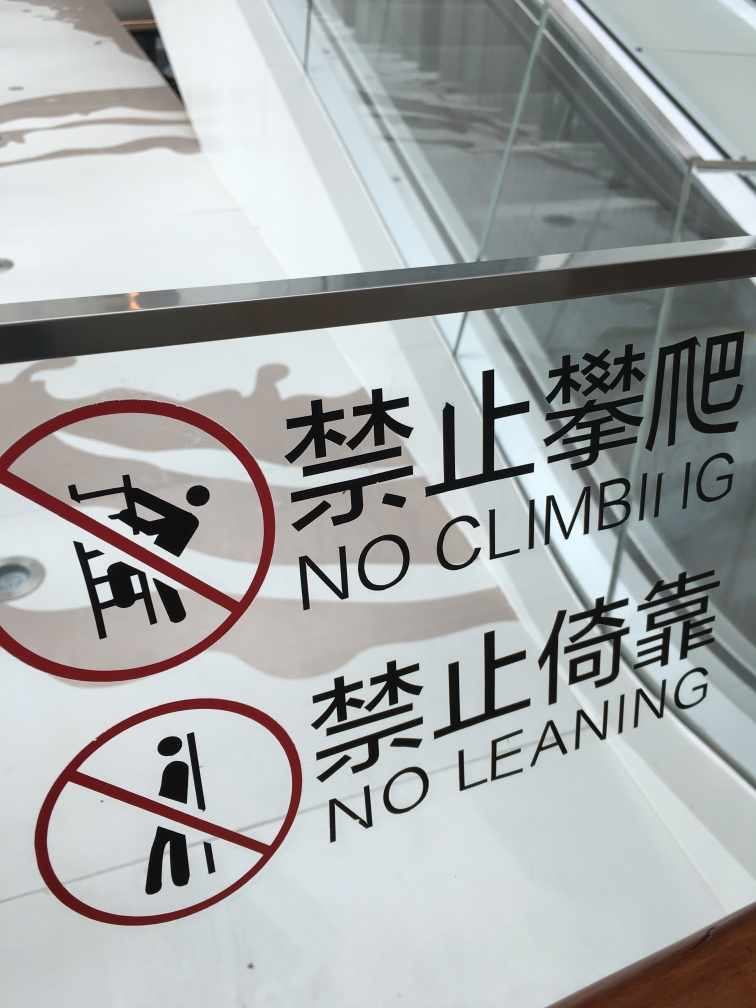What does the text on the sign indicate about the behavior expected in this area? The text on the sign, displayed in both English and Chinese, clearly instructs individuals not to climb or lean on the surface. This suggests a concern for safety, possibly to prevent accidents or damage. 